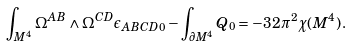Convert formula to latex. <formula><loc_0><loc_0><loc_500><loc_500>\int _ { M ^ { 4 } } \Omega ^ { A B } \wedge \Omega ^ { C D } \epsilon _ { A B C D 0 } - \int _ { \partial M ^ { 4 } } Q _ { 0 } = - 3 2 \pi ^ { 2 } \chi ( M ^ { 4 } ) \, .</formula> 